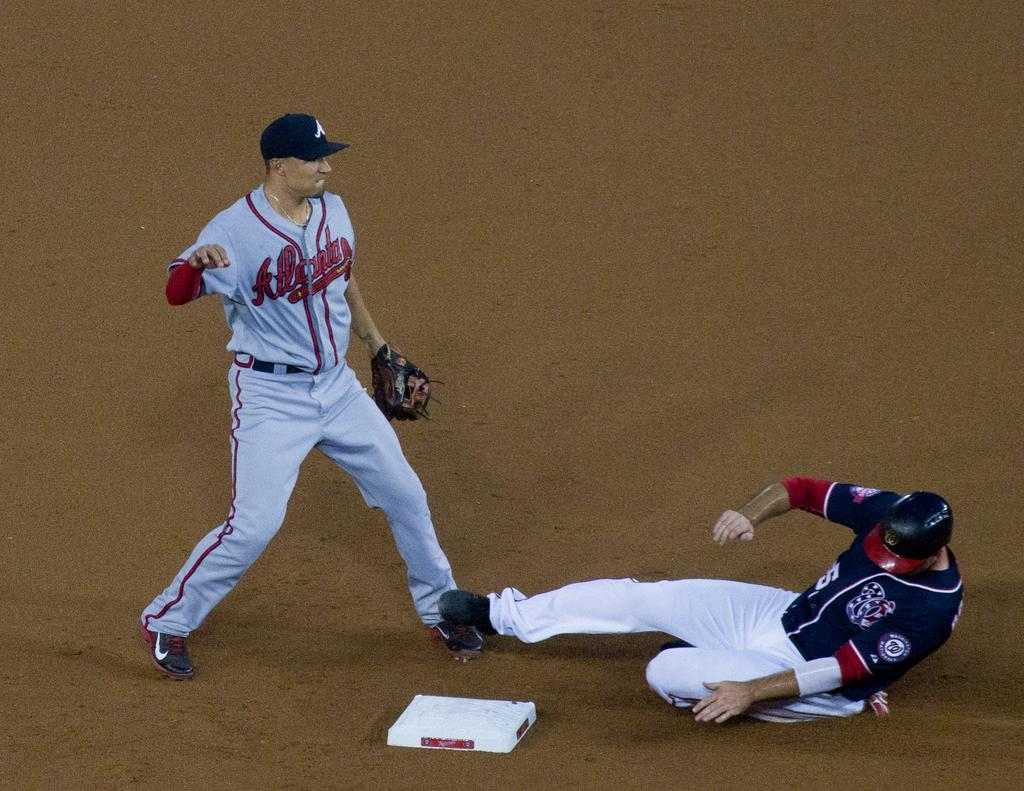<image>
Offer a succinct explanation of the picture presented. An Atalanta baseball player standing next to a base while a player from the opposing team is on the ground opposite him. 